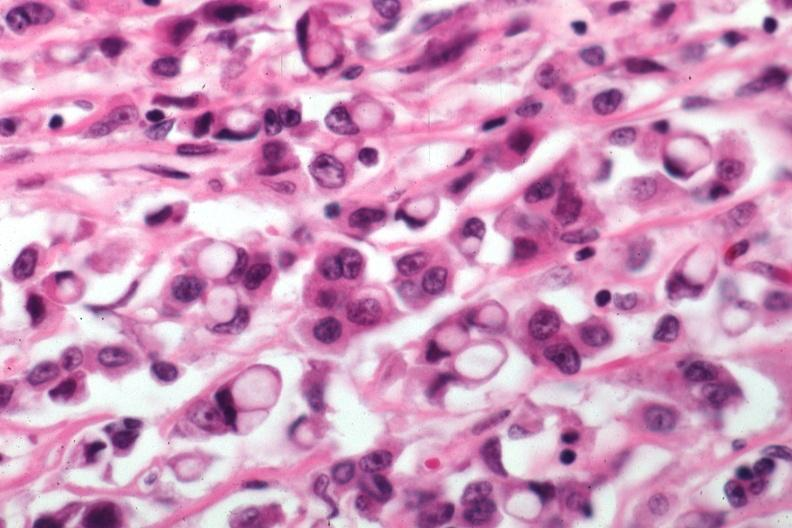does this image show pleomorphic cells with obvious mucin secretion?
Answer the question using a single word or phrase. Yes 